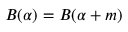<formula> <loc_0><loc_0><loc_500><loc_500>B ( \alpha ) = B ( \alpha + m )</formula> 